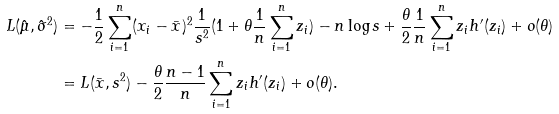Convert formula to latex. <formula><loc_0><loc_0><loc_500><loc_500>L ( \hat { \mu } , \hat { \sigma } ^ { 2 } ) & = - \frac { 1 } { 2 } \sum _ { i = 1 } ^ { n } ( x _ { i } - \bar { x } ) ^ { 2 } \frac { 1 } { s ^ { 2 } } ( 1 + \theta \frac { 1 } { n } \sum _ { i = 1 } ^ { n } z _ { i } ) - n \log s + \frac { \theta } { 2 } \frac { 1 } { n } \sum _ { i = 1 } ^ { n } z _ { i } h ^ { \prime } ( z _ { i } ) + o ( \theta ) \\ & = L ( \bar { x } , s ^ { 2 } ) - \frac { \theta } { 2 } \frac { n - 1 } { n } \sum _ { i = 1 } ^ { n } z _ { i } h ^ { \prime } ( z _ { i } ) + o ( \theta ) .</formula> 